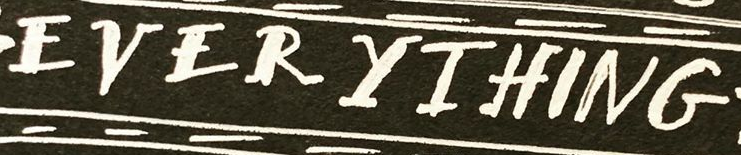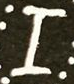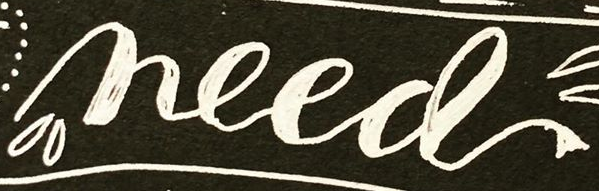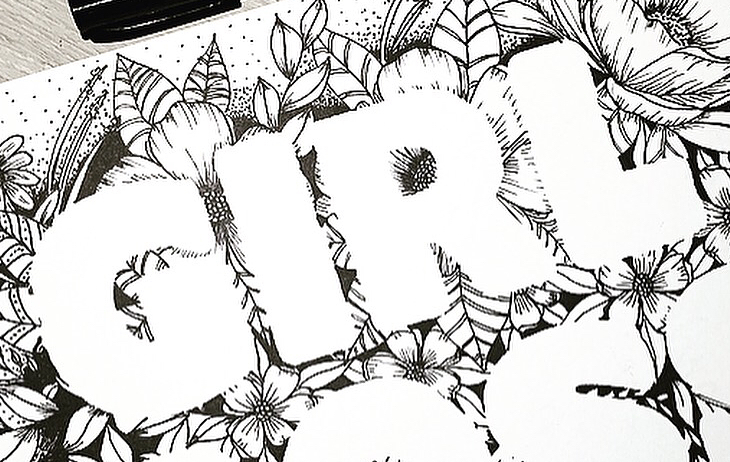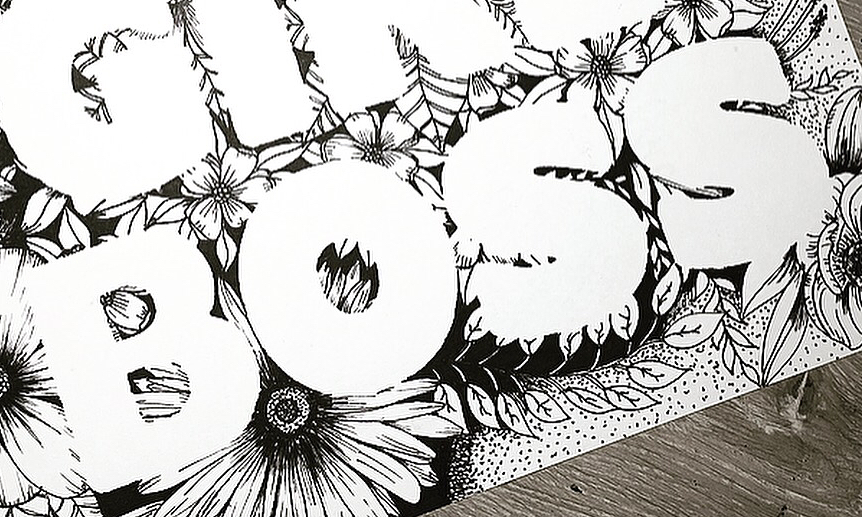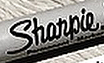Read the text from these images in sequence, separated by a semicolon. EVERYIHING; I; need; GIRL; BOSS; Shanpie 